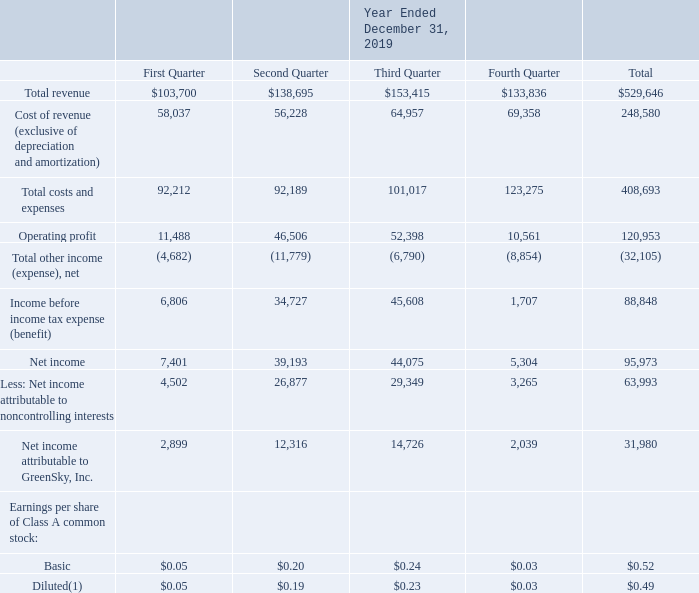GreenSky, Inc. NOTES TO CONSOLIDATED FINANCIAL STATEMENTS — (Continued) (United States Dollars in thousands, except per share data, unless otherwise stated)
Note 18. Quarterly Consolidated Results of Operations Data (Unaudited)
The following table sets forth our quarterly consolidated results of operations data for each of the eight quarters in the period ended December 31, 2019. GS Holdings is our predecessor for accounting purposes and, accordingly, amounts prior to the Reorganization Transactions and IPO represent the historical consolidated operations of GS Holdings and its subsidiaries. The amounts during the period from May 24, 2018 through December 31, 2018 represent those of consolidated GreenSky, Inc. and its subsidiaries. Basic and diluted earnings per share of Class A common stock is applicable only for the period from May 24, 2018 through December 31, 2018, which is the period following the Reorganization Transactions and IPO. Prior to the Reorganization Transactions and IPO, GreenSky, Inc. did not engage in any business or other activities except in connection with its formation and initial capitalization. See Note 1 for further information on our organization and see Note 2 for further information on our earnings per share.
(1) Year-to-date results may not agree to the sum of individual quarterly results due to rounding.
What was the total revenue for 2019?
Answer scale should be: thousand. 529,646. What was the operating profit in the first quarter?
Answer scale should be: thousand. 11,488. What was the net income in the third quarter?
Answer scale should be: thousand. 44,075. How many quarters did the the Net Income exceed $10,000 thousand? Second quarter##third quarter
answer: 2. What was the change in operating profit between the third and fourth quarter?
Answer scale should be: thousand. 10,561-52,398
Answer: -41837. What was the percentage change in the basic earnings per share of Class A common stock between the first and second quarter?
Answer scale should be: percent. (0.20-0.05)/0.05
Answer: 300. 